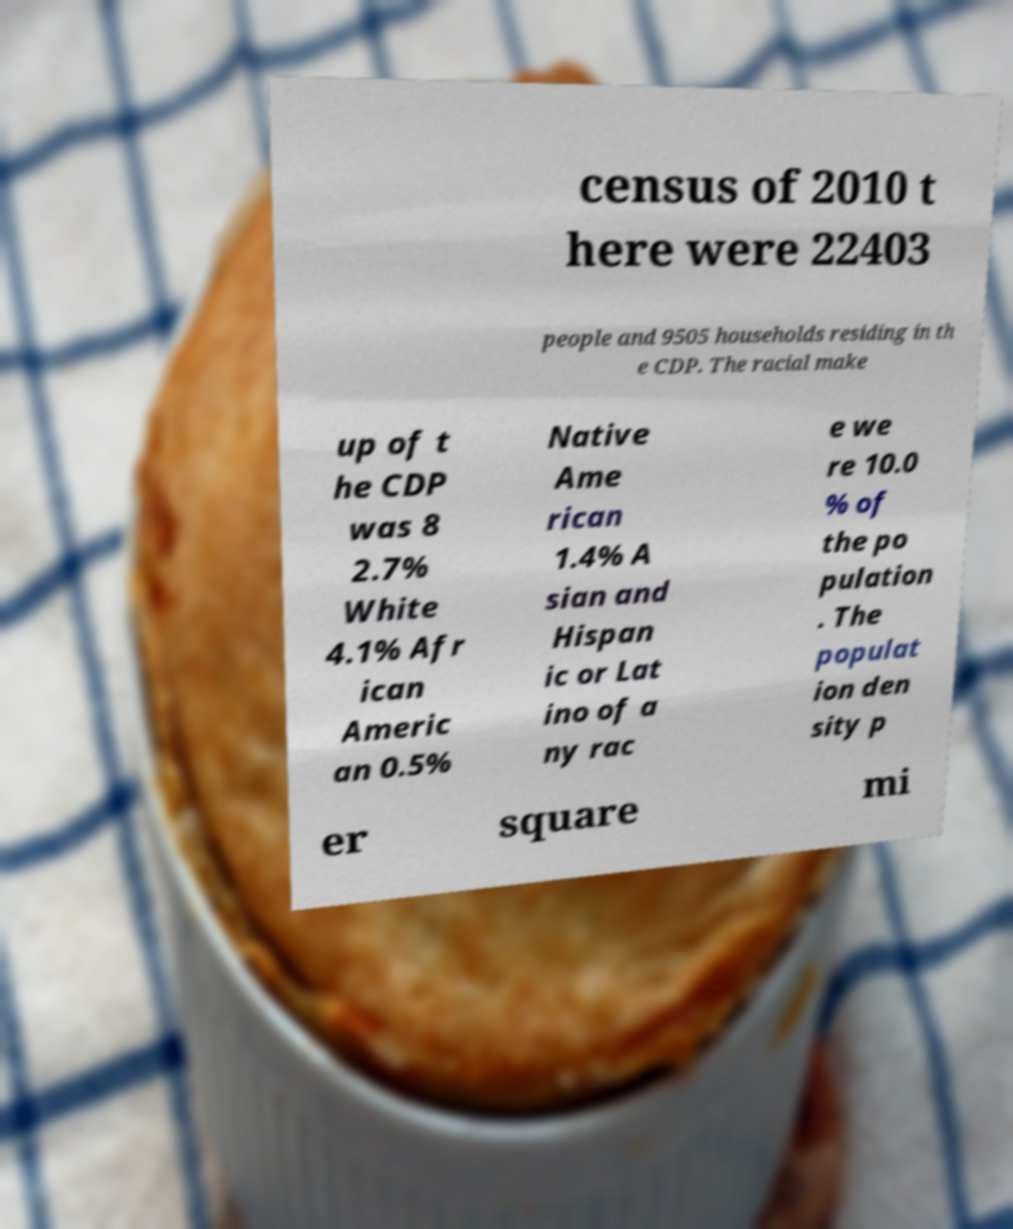Please identify and transcribe the text found in this image. census of 2010 t here were 22403 people and 9505 households residing in th e CDP. The racial make up of t he CDP was 8 2.7% White 4.1% Afr ican Americ an 0.5% Native Ame rican 1.4% A sian and Hispan ic or Lat ino of a ny rac e we re 10.0 % of the po pulation . The populat ion den sity p er square mi 